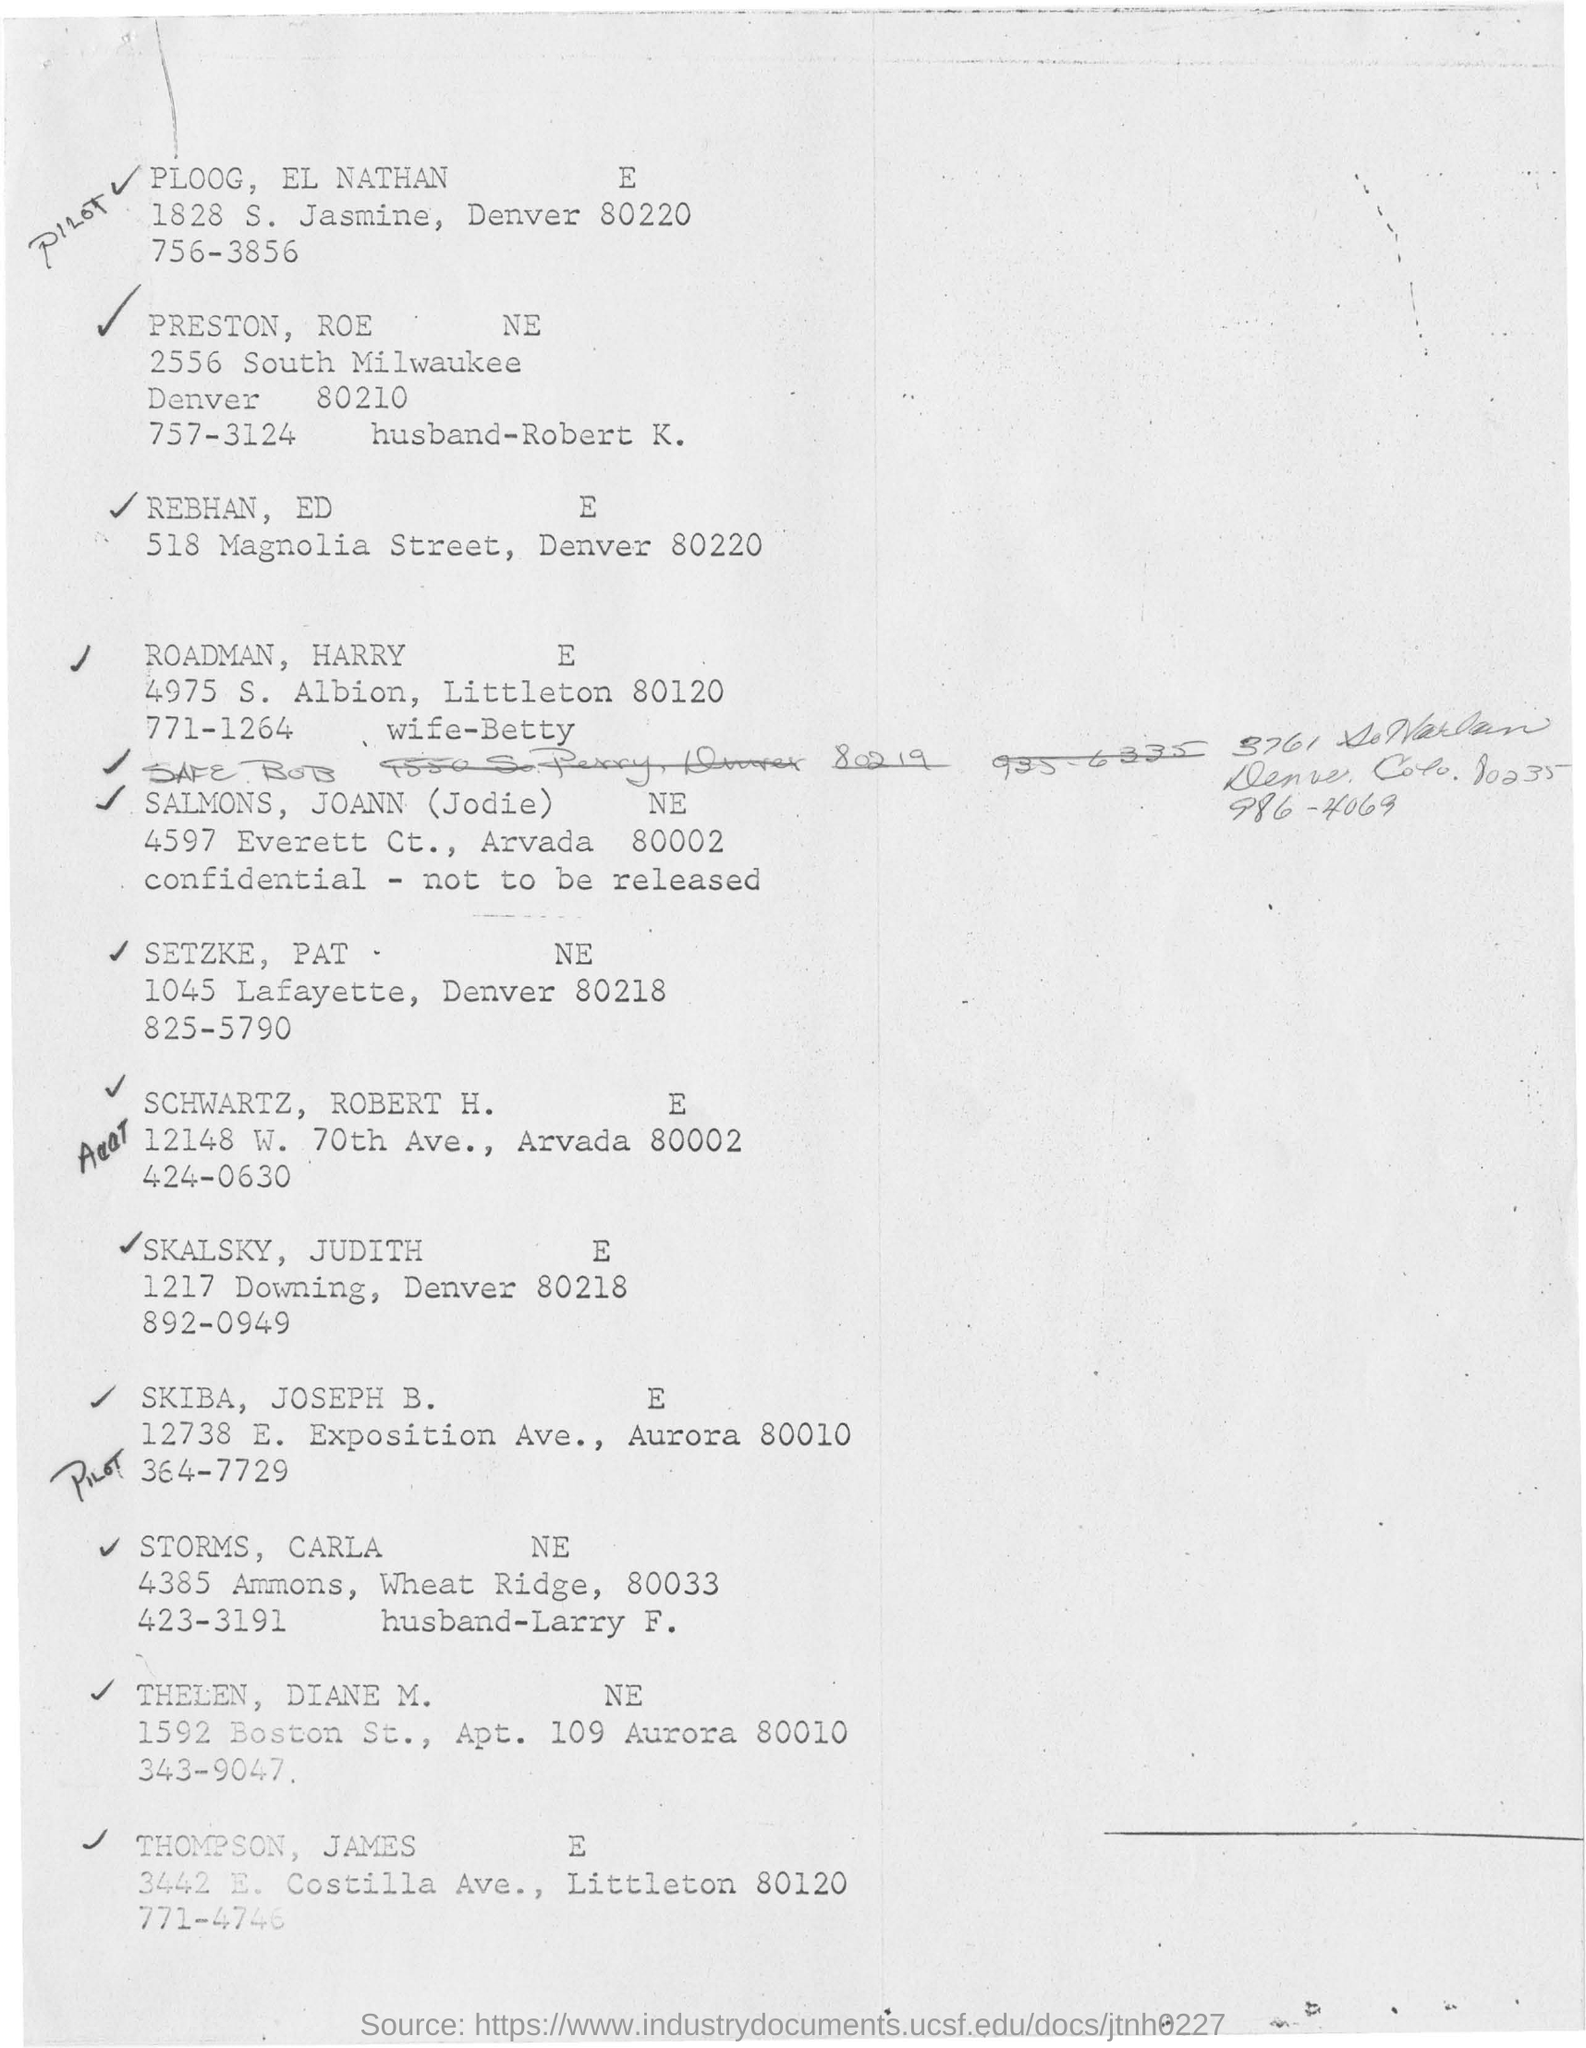What is the handwritten word in the top of the document?
Offer a terse response. PILOT. What is the first name in the list?
Make the answer very short. PLOOG, EL NATHAN. What is the second last name mentioned?
Offer a very short reply. THELEN, DIANE M. What is the address mentioned under the name of REBHAN, ED?
Give a very brief answer. 518 Magnolia Street, Denver 80220. 